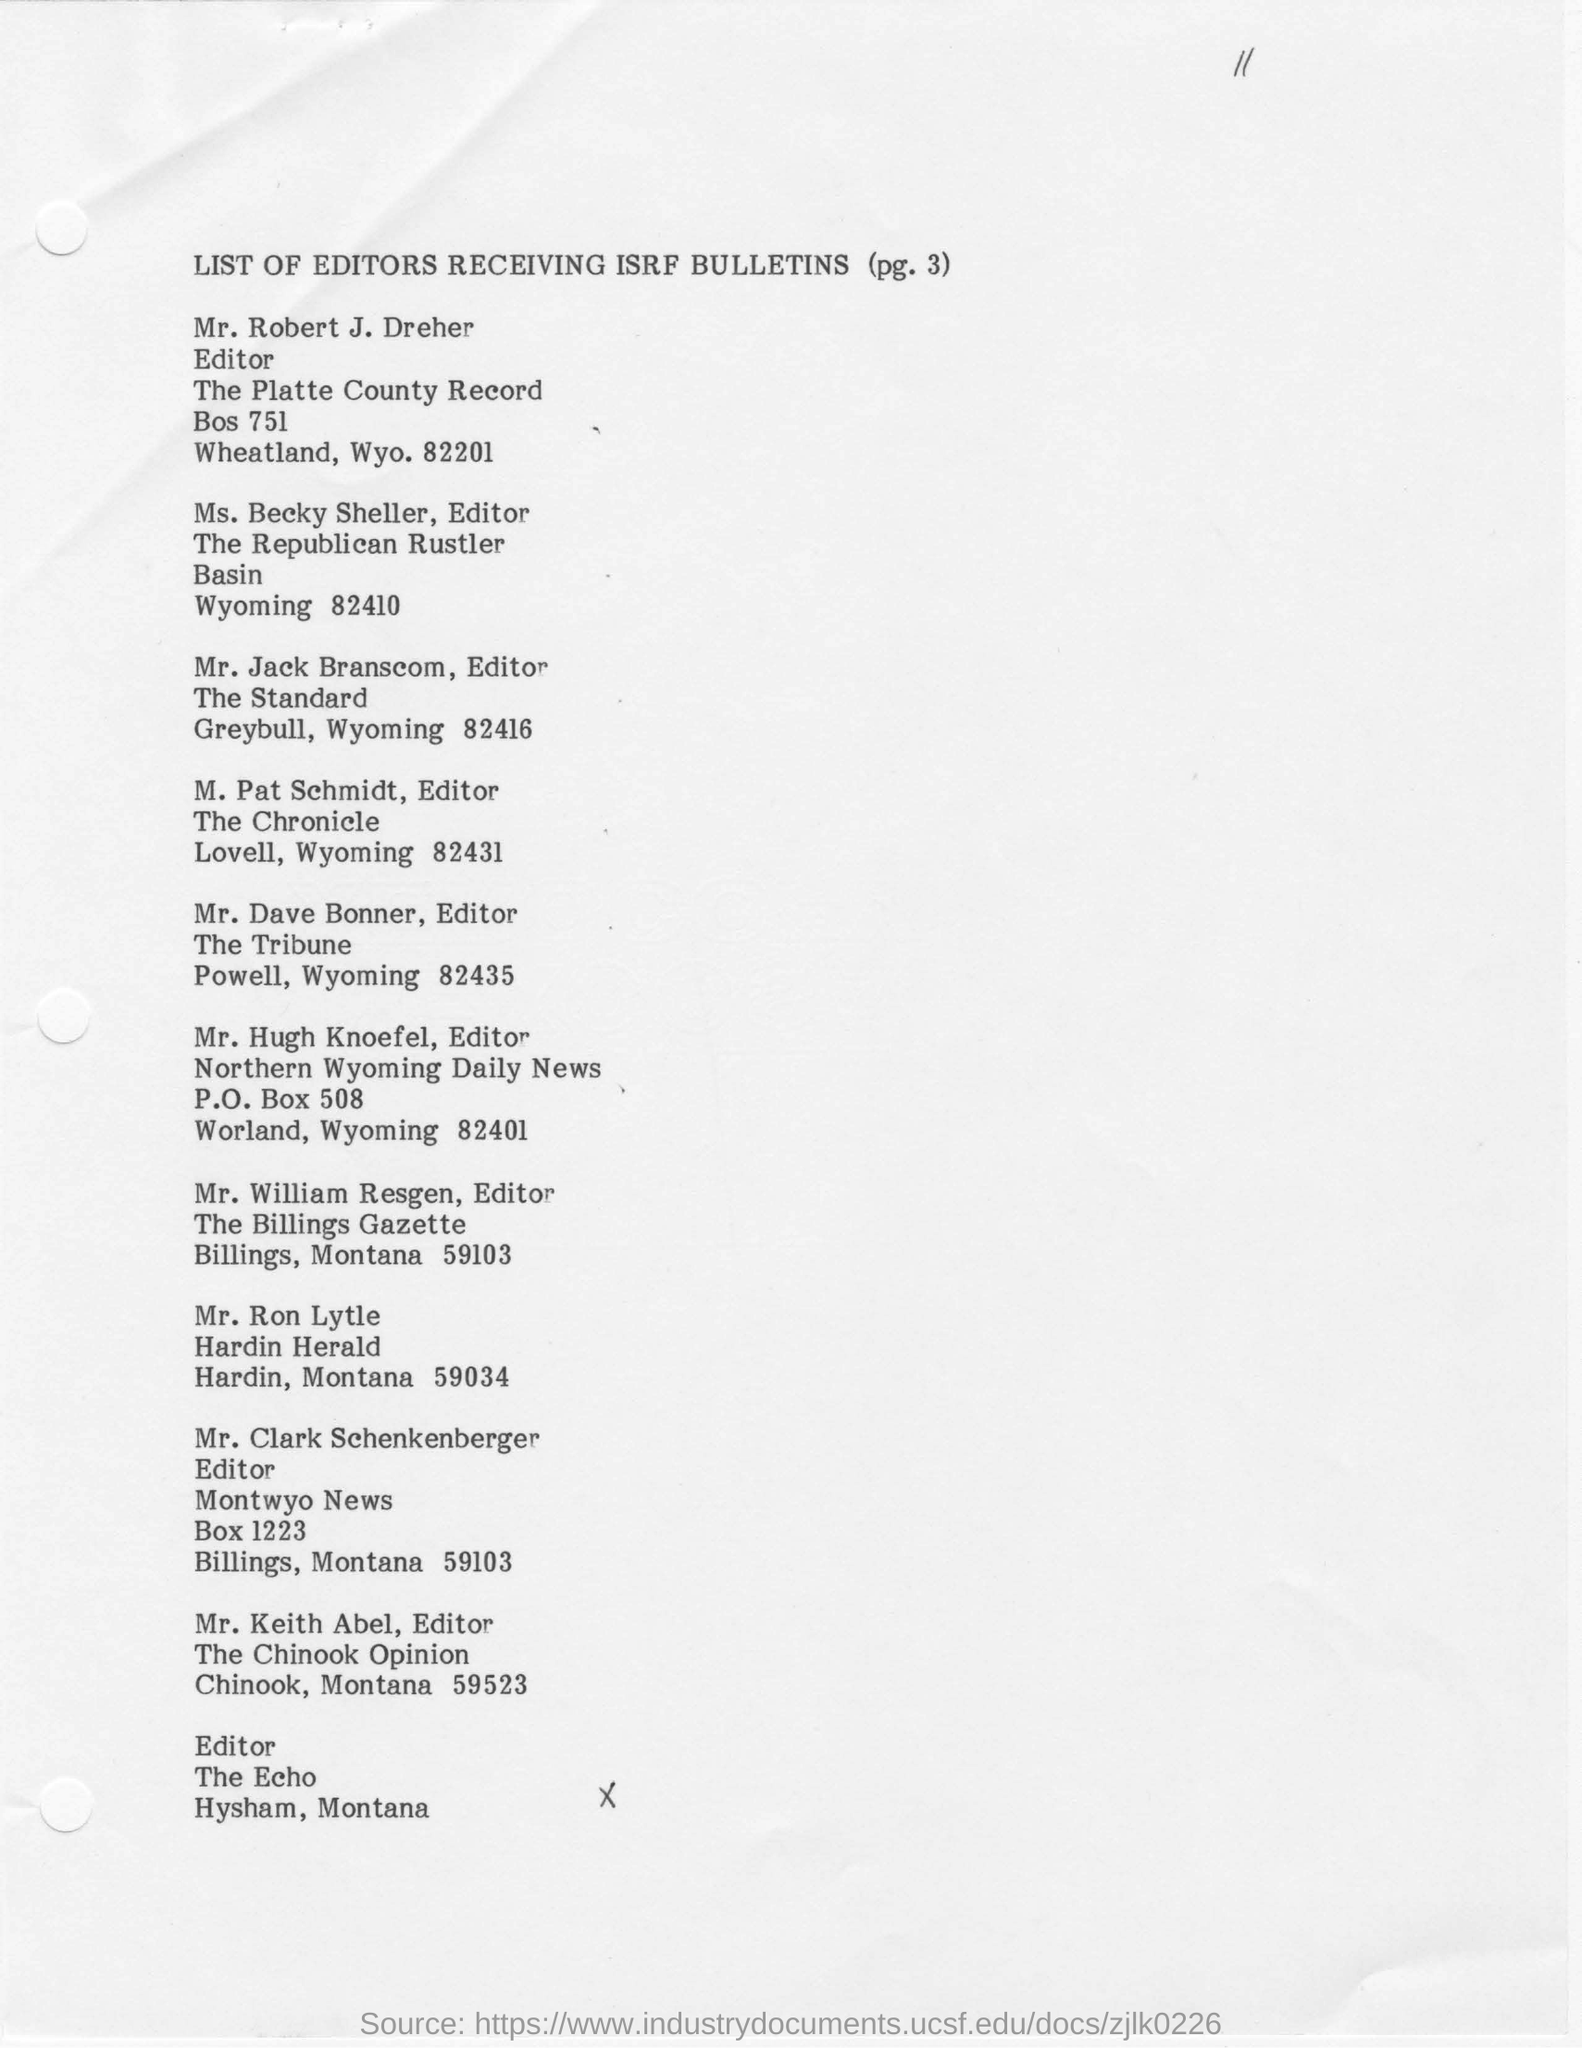Indicate a few pertinent items in this graphic. M. Pat Schmidt is the editor for The Chronicle. The page that contains the list of editors is page 3. 